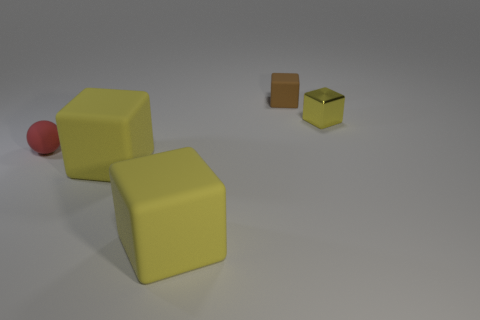What number of other things are the same shape as the red rubber object?
Give a very brief answer. 0. Does the yellow cube on the right side of the brown rubber thing have the same size as the object behind the small metal object?
Ensure brevity in your answer.  Yes. Is there anything else that has the same material as the small yellow block?
Your response must be concise. No. There is a yellow cube that is behind the tiny ball in front of the small matte object that is to the right of the small rubber sphere; what is it made of?
Your answer should be compact. Metal. Is the small brown thing the same shape as the small yellow object?
Keep it short and to the point. Yes. There is another small thing that is the same shape as the tiny shiny object; what is its material?
Provide a succinct answer. Rubber. What number of other objects are the same color as the shiny object?
Keep it short and to the point. 2. The red object that is made of the same material as the tiny brown block is what size?
Your response must be concise. Small. What number of yellow objects are either shiny cubes or large matte cubes?
Your answer should be compact. 3. How many red things are right of the yellow cube behind the tiny rubber ball?
Your answer should be compact. 0. 